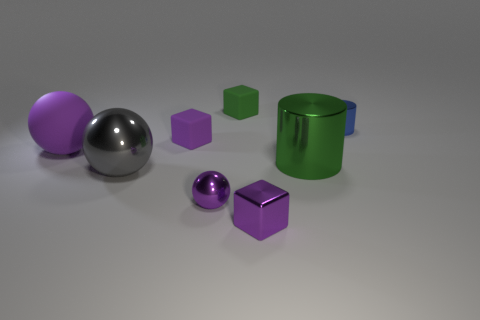Is the color of the big matte ball the same as the small shiny block?
Your answer should be very brief. Yes. There is a tiny rubber block in front of the tiny blue object; does it have the same color as the small metallic ball?
Give a very brief answer. Yes. Is there a metal cylinder that is right of the matte block that is on the left side of the tiny green thing?
Provide a succinct answer. Yes. There is a thing that is both behind the big gray shiny thing and in front of the rubber sphere; what is its material?
Keep it short and to the point. Metal. The small green object that is made of the same material as the big purple thing is what shape?
Offer a terse response. Cube. Are the green object that is in front of the blue shiny thing and the green cube made of the same material?
Your response must be concise. No. What material is the block that is in front of the big matte sphere?
Make the answer very short. Metal. What is the size of the purple cube that is on the right side of the tiny purple thing that is behind the large green thing?
Offer a very short reply. Small. How many blue objects have the same size as the green cube?
Your answer should be compact. 1. Is the color of the rubber cube behind the blue shiny object the same as the cylinder that is in front of the rubber sphere?
Offer a terse response. Yes. 